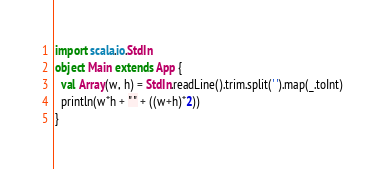<code> <loc_0><loc_0><loc_500><loc_500><_Scala_>import scala.io.StdIn
object Main extends App {
  val Array(w, h) = StdIn.readLine().trim.split(' ').map(_.toInt)
  println(w*h + " " + ((w+h)*2))
}

</code> 